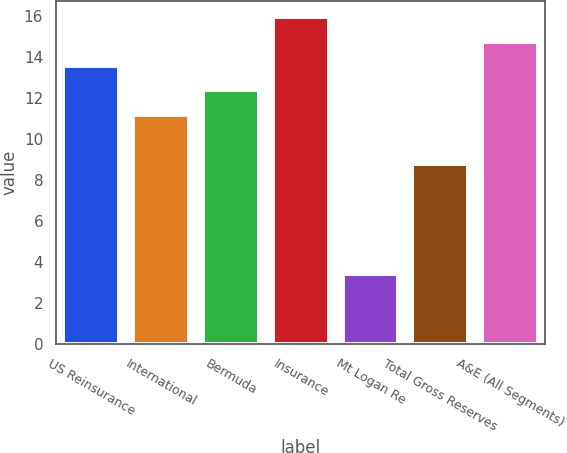<chart> <loc_0><loc_0><loc_500><loc_500><bar_chart><fcel>US Reinsurance<fcel>International<fcel>Bermuda<fcel>Insurance<fcel>Mt Logan Re<fcel>Total Gross Reserves<fcel>A&E (All Segments)<nl><fcel>13.56<fcel>11.18<fcel>12.37<fcel>15.94<fcel>3.42<fcel>8.8<fcel>14.75<nl></chart> 